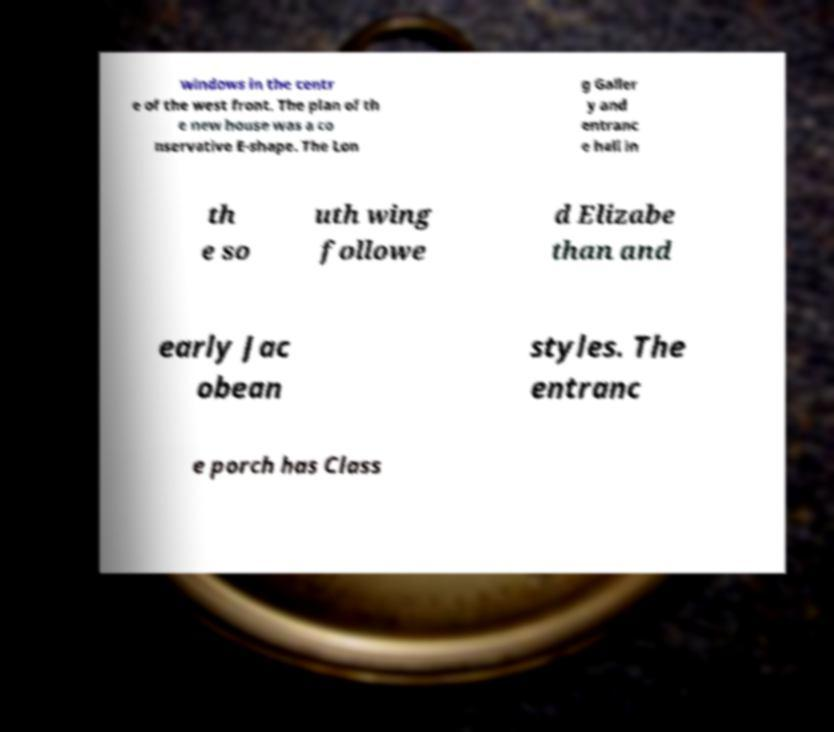Could you extract and type out the text from this image? windows in the centr e of the west front. The plan of th e new house was a co nservative E-shape. The Lon g Galler y and entranc e hall in th e so uth wing followe d Elizabe than and early Jac obean styles. The entranc e porch has Class 